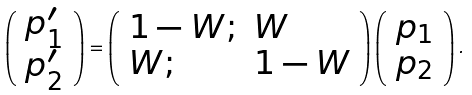Convert formula to latex. <formula><loc_0><loc_0><loc_500><loc_500>\left ( \begin{array} { l } { p _ { 1 } ^ { \prime } } \\ { p _ { 2 } ^ { \prime } } \end{array} \right ) = \left ( \begin{array} { l l } { 1 - W ; } & { W } \\ { W ; } & { 1 - W } \end{array} \right ) \left ( \begin{array} { l } { p _ { 1 } } \\ { p _ { 2 } } \end{array} \right ) .</formula> 